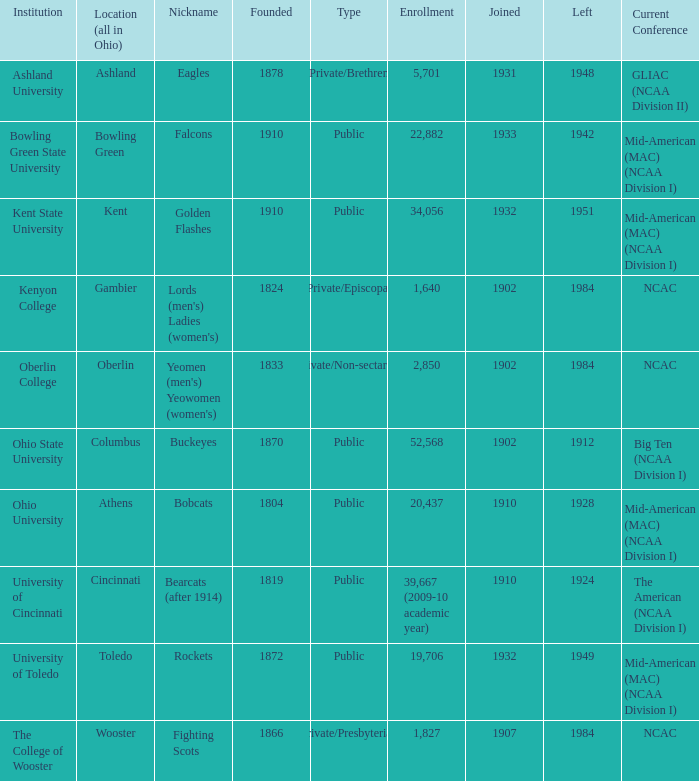What is the enrollment for Ashland University? 5701.0. 